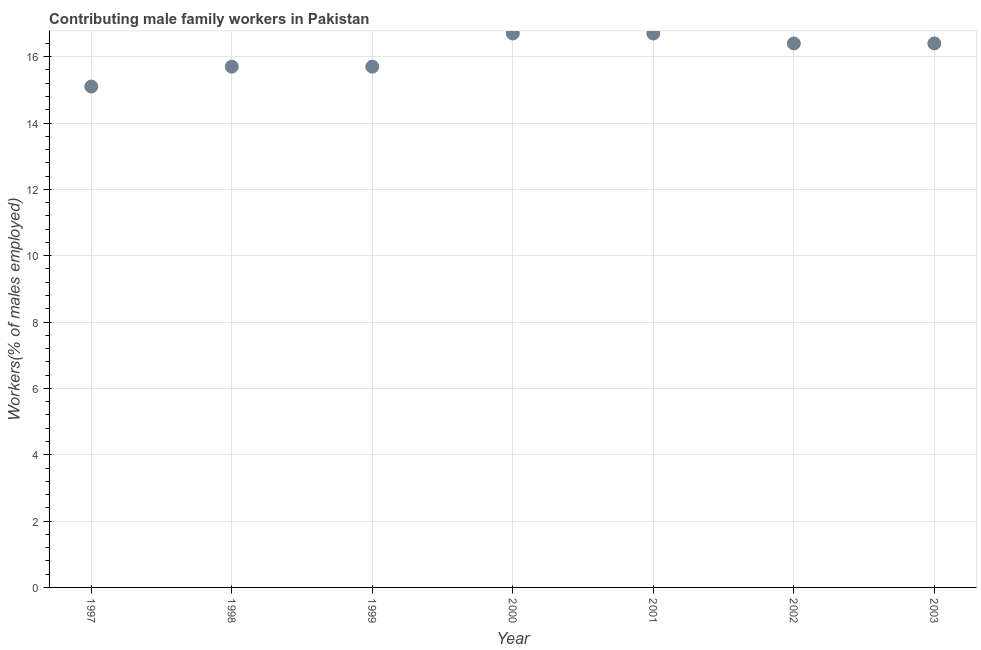What is the contributing male family workers in 2000?
Offer a terse response. 16.7. Across all years, what is the maximum contributing male family workers?
Make the answer very short. 16.7. Across all years, what is the minimum contributing male family workers?
Ensure brevity in your answer.  15.1. What is the sum of the contributing male family workers?
Offer a very short reply. 112.7. What is the difference between the contributing male family workers in 1999 and 2002?
Your answer should be compact. -0.7. What is the average contributing male family workers per year?
Ensure brevity in your answer.  16.1. What is the median contributing male family workers?
Ensure brevity in your answer.  16.4. In how many years, is the contributing male family workers greater than 12 %?
Your answer should be very brief. 7. What is the ratio of the contributing male family workers in 2000 to that in 2002?
Your response must be concise. 1.02. Is the difference between the contributing male family workers in 1998 and 2002 greater than the difference between any two years?
Your answer should be compact. No. What is the difference between the highest and the second highest contributing male family workers?
Your response must be concise. 0. What is the difference between the highest and the lowest contributing male family workers?
Offer a very short reply. 1.6. Does the contributing male family workers monotonically increase over the years?
Your answer should be very brief. No. Are the values on the major ticks of Y-axis written in scientific E-notation?
Ensure brevity in your answer.  No. What is the title of the graph?
Give a very brief answer. Contributing male family workers in Pakistan. What is the label or title of the Y-axis?
Make the answer very short. Workers(% of males employed). What is the Workers(% of males employed) in 1997?
Ensure brevity in your answer.  15.1. What is the Workers(% of males employed) in 1998?
Your answer should be compact. 15.7. What is the Workers(% of males employed) in 1999?
Ensure brevity in your answer.  15.7. What is the Workers(% of males employed) in 2000?
Your answer should be very brief. 16.7. What is the Workers(% of males employed) in 2001?
Keep it short and to the point. 16.7. What is the Workers(% of males employed) in 2002?
Ensure brevity in your answer.  16.4. What is the Workers(% of males employed) in 2003?
Your answer should be compact. 16.4. What is the difference between the Workers(% of males employed) in 1997 and 1999?
Your answer should be very brief. -0.6. What is the difference between the Workers(% of males employed) in 1997 and 2000?
Provide a succinct answer. -1.6. What is the difference between the Workers(% of males employed) in 1997 and 2002?
Offer a very short reply. -1.3. What is the difference between the Workers(% of males employed) in 1998 and 1999?
Your answer should be compact. 0. What is the difference between the Workers(% of males employed) in 1998 and 2000?
Your answer should be very brief. -1. What is the difference between the Workers(% of males employed) in 1998 and 2001?
Your answer should be compact. -1. What is the difference between the Workers(% of males employed) in 1998 and 2002?
Make the answer very short. -0.7. What is the difference between the Workers(% of males employed) in 1998 and 2003?
Your response must be concise. -0.7. What is the difference between the Workers(% of males employed) in 1999 and 2001?
Offer a very short reply. -1. What is the difference between the Workers(% of males employed) in 1999 and 2002?
Provide a succinct answer. -0.7. What is the difference between the Workers(% of males employed) in 2000 and 2001?
Give a very brief answer. 0. What is the difference between the Workers(% of males employed) in 2000 and 2002?
Make the answer very short. 0.3. What is the difference between the Workers(% of males employed) in 2001 and 2003?
Offer a very short reply. 0.3. What is the ratio of the Workers(% of males employed) in 1997 to that in 1999?
Ensure brevity in your answer.  0.96. What is the ratio of the Workers(% of males employed) in 1997 to that in 2000?
Offer a terse response. 0.9. What is the ratio of the Workers(% of males employed) in 1997 to that in 2001?
Ensure brevity in your answer.  0.9. What is the ratio of the Workers(% of males employed) in 1997 to that in 2002?
Your answer should be compact. 0.92. What is the ratio of the Workers(% of males employed) in 1997 to that in 2003?
Make the answer very short. 0.92. What is the ratio of the Workers(% of males employed) in 1998 to that in 1999?
Your answer should be compact. 1. What is the ratio of the Workers(% of males employed) in 1998 to that in 2000?
Make the answer very short. 0.94. What is the ratio of the Workers(% of males employed) in 1998 to that in 2001?
Keep it short and to the point. 0.94. What is the ratio of the Workers(% of males employed) in 1998 to that in 2003?
Provide a short and direct response. 0.96. What is the ratio of the Workers(% of males employed) in 1999 to that in 2002?
Your answer should be very brief. 0.96. What is the ratio of the Workers(% of males employed) in 1999 to that in 2003?
Offer a very short reply. 0.96. What is the ratio of the Workers(% of males employed) in 2000 to that in 2002?
Provide a succinct answer. 1.02. What is the ratio of the Workers(% of males employed) in 2000 to that in 2003?
Give a very brief answer. 1.02. What is the ratio of the Workers(% of males employed) in 2002 to that in 2003?
Keep it short and to the point. 1. 